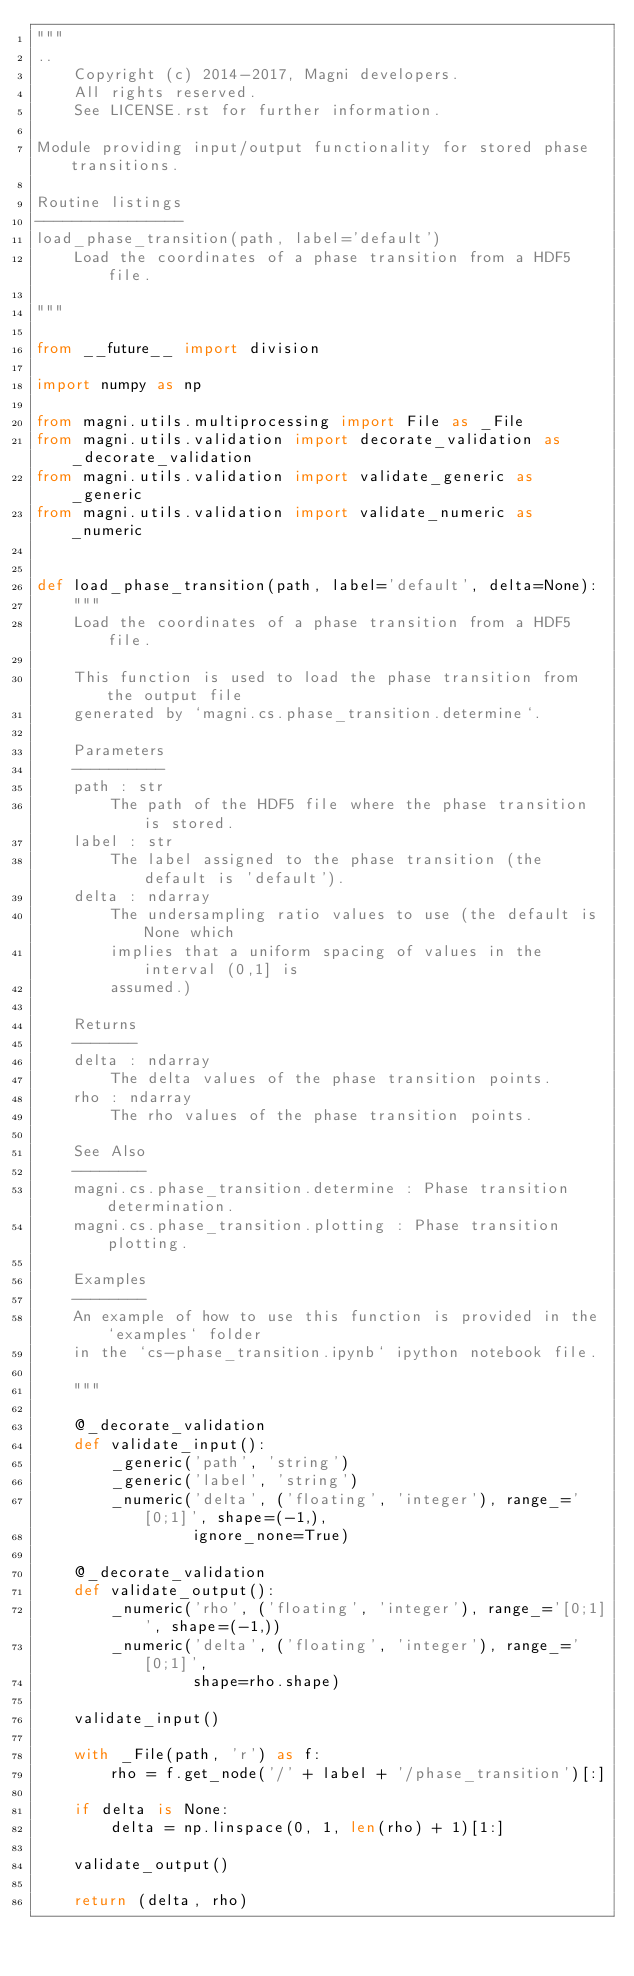Convert code to text. <code><loc_0><loc_0><loc_500><loc_500><_Python_>"""
..
    Copyright (c) 2014-2017, Magni developers.
    All rights reserved.
    See LICENSE.rst for further information.

Module providing input/output functionality for stored phase transitions.

Routine listings
----------------
load_phase_transition(path, label='default')
    Load the coordinates of a phase transition from a HDF5 file.

"""

from __future__ import division

import numpy as np

from magni.utils.multiprocessing import File as _File
from magni.utils.validation import decorate_validation as _decorate_validation
from magni.utils.validation import validate_generic as _generic
from magni.utils.validation import validate_numeric as _numeric


def load_phase_transition(path, label='default', delta=None):
    """
    Load the coordinates of a phase transition from a HDF5 file.

    This function is used to load the phase transition from the output file
    generated by `magni.cs.phase_transition.determine`.

    Parameters
    ----------
    path : str
        The path of the HDF5 file where the phase transition is stored.
    label : str
        The label assigned to the phase transition (the default is 'default').
    delta : ndarray
        The undersampling ratio values to use (the default is None which
        implies that a uniform spacing of values in the interval (0,1] is
        assumed.)

    Returns
    -------
    delta : ndarray
        The delta values of the phase transition points.
    rho : ndarray
        The rho values of the phase transition points.

    See Also
    --------
    magni.cs.phase_transition.determine : Phase transition determination.
    magni.cs.phase_transition.plotting : Phase transition plotting.

    Examples
    --------
    An example of how to use this function is provided in the `examples` folder
    in the `cs-phase_transition.ipynb` ipython notebook file.

    """

    @_decorate_validation
    def validate_input():
        _generic('path', 'string')
        _generic('label', 'string')
        _numeric('delta', ('floating', 'integer'), range_='[0;1]', shape=(-1,),
                 ignore_none=True)

    @_decorate_validation
    def validate_output():
        _numeric('rho', ('floating', 'integer'), range_='[0;1]', shape=(-1,))
        _numeric('delta', ('floating', 'integer'), range_='[0;1]',
                 shape=rho.shape)

    validate_input()

    with _File(path, 'r') as f:
        rho = f.get_node('/' + label + '/phase_transition')[:]

    if delta is None:
        delta = np.linspace(0, 1, len(rho) + 1)[1:]

    validate_output()

    return (delta, rho)
</code> 